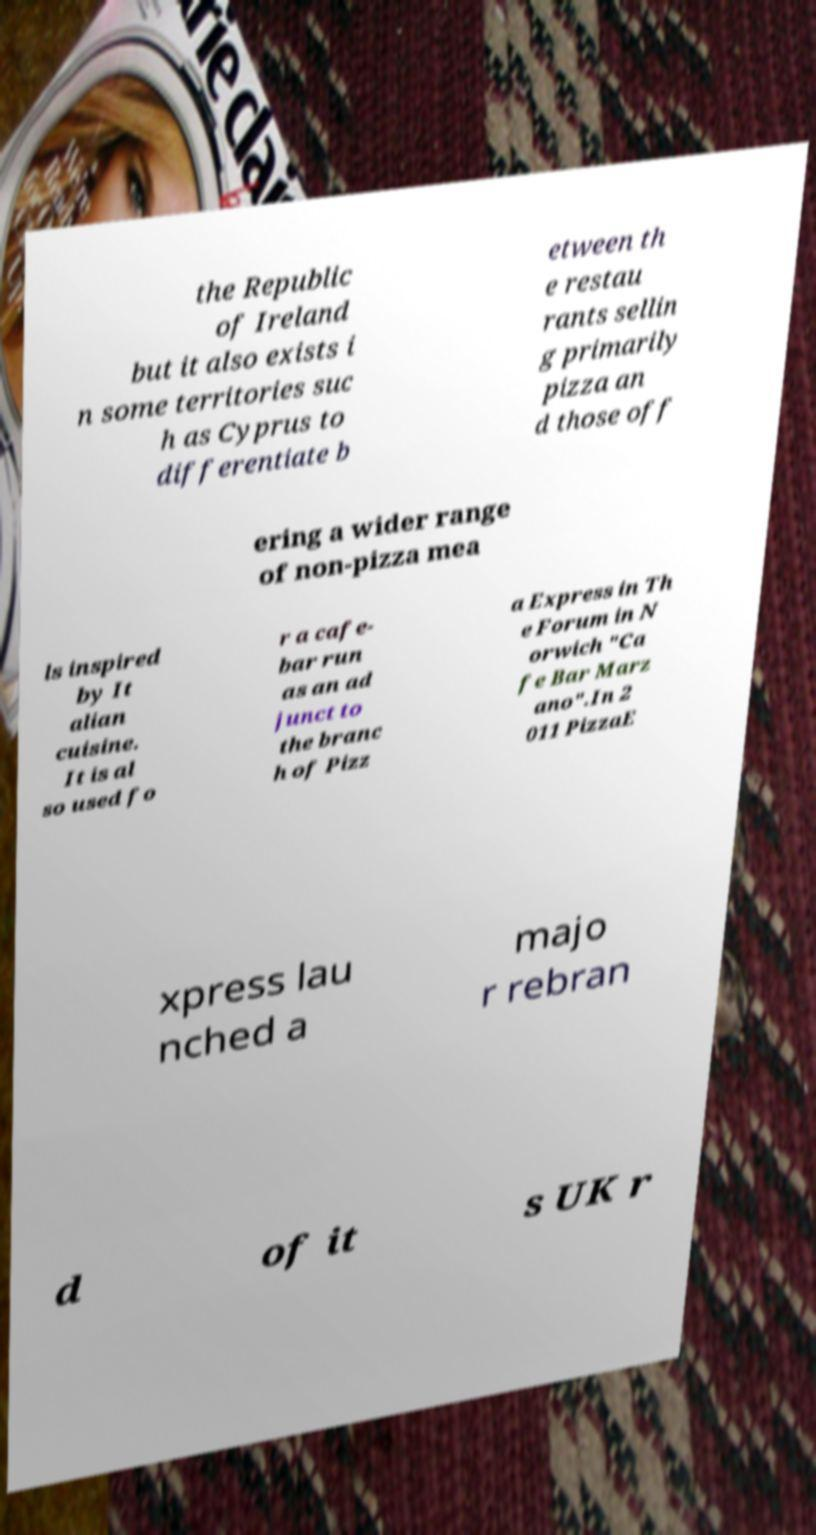Can you read and provide the text displayed in the image?This photo seems to have some interesting text. Can you extract and type it out for me? the Republic of Ireland but it also exists i n some territories suc h as Cyprus to differentiate b etween th e restau rants sellin g primarily pizza an d those off ering a wider range of non-pizza mea ls inspired by It alian cuisine. It is al so used fo r a cafe- bar run as an ad junct to the branc h of Pizz a Express in Th e Forum in N orwich "Ca fe Bar Marz ano".In 2 011 PizzaE xpress lau nched a majo r rebran d of it s UK r 